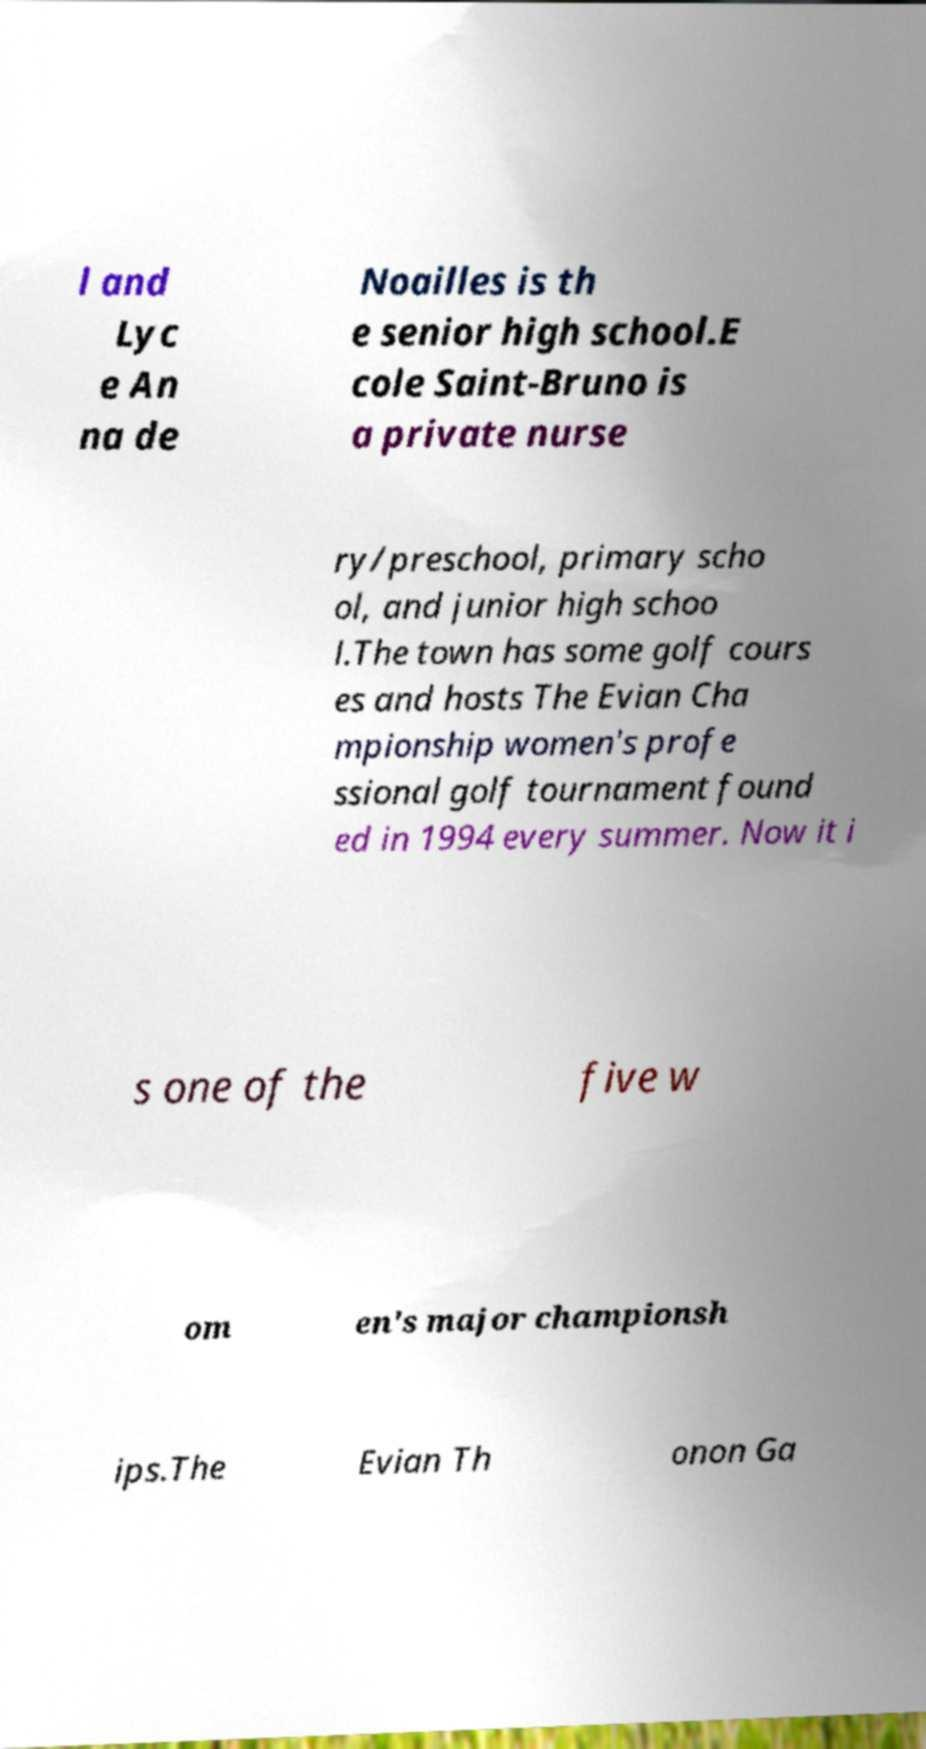Please read and relay the text visible in this image. What does it say? l and Lyc e An na de Noailles is th e senior high school.E cole Saint-Bruno is a private nurse ry/preschool, primary scho ol, and junior high schoo l.The town has some golf cours es and hosts The Evian Cha mpionship women's profe ssional golf tournament found ed in 1994 every summer. Now it i s one of the five w om en's major championsh ips.The Evian Th onon Ga 